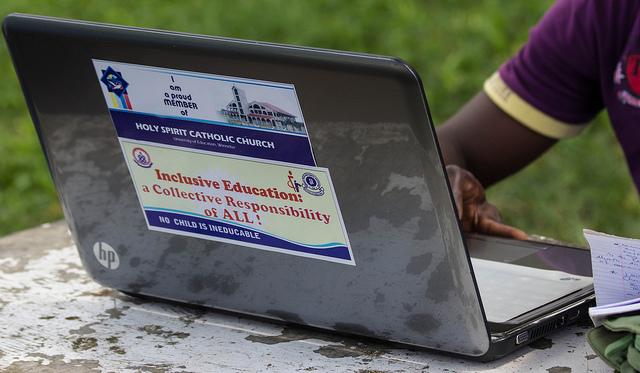What color skin does the person have?
Keep it brief. Black. Does it appear the student paid for this laptop?
Short answer required. No. What brand is this computer?
Quick response, please. Hp. 